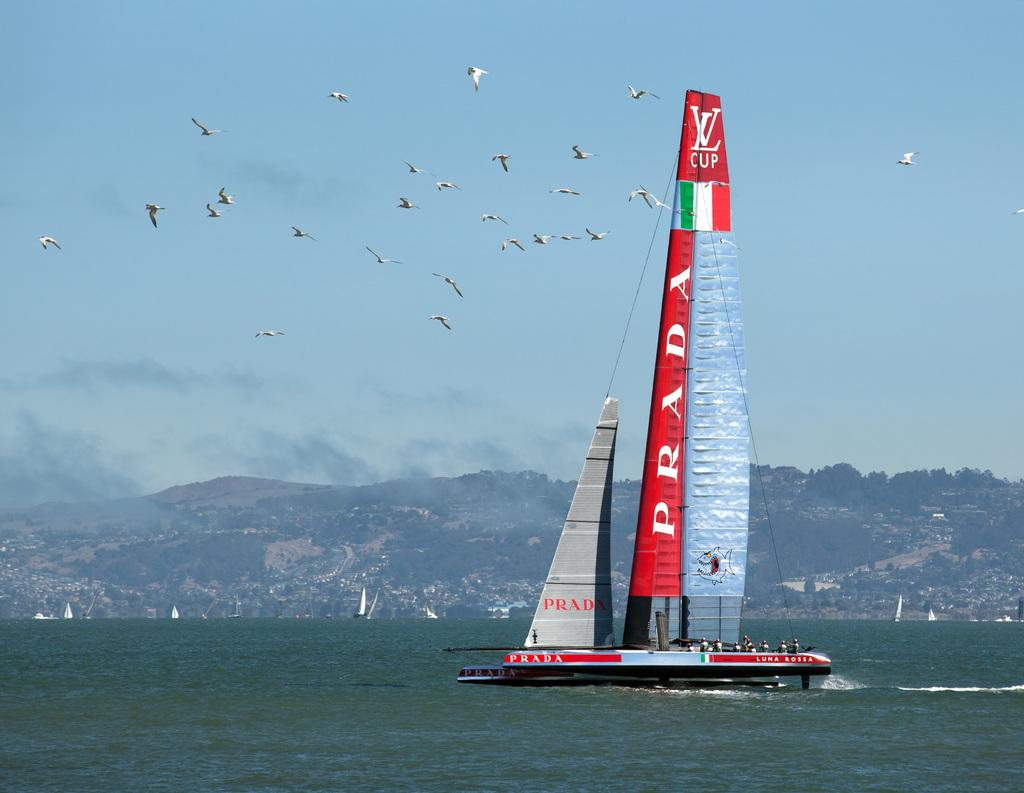<image>
Provide a brief description of the given image. A sailboat sponsored by Prada is competing in the VL Cup. 